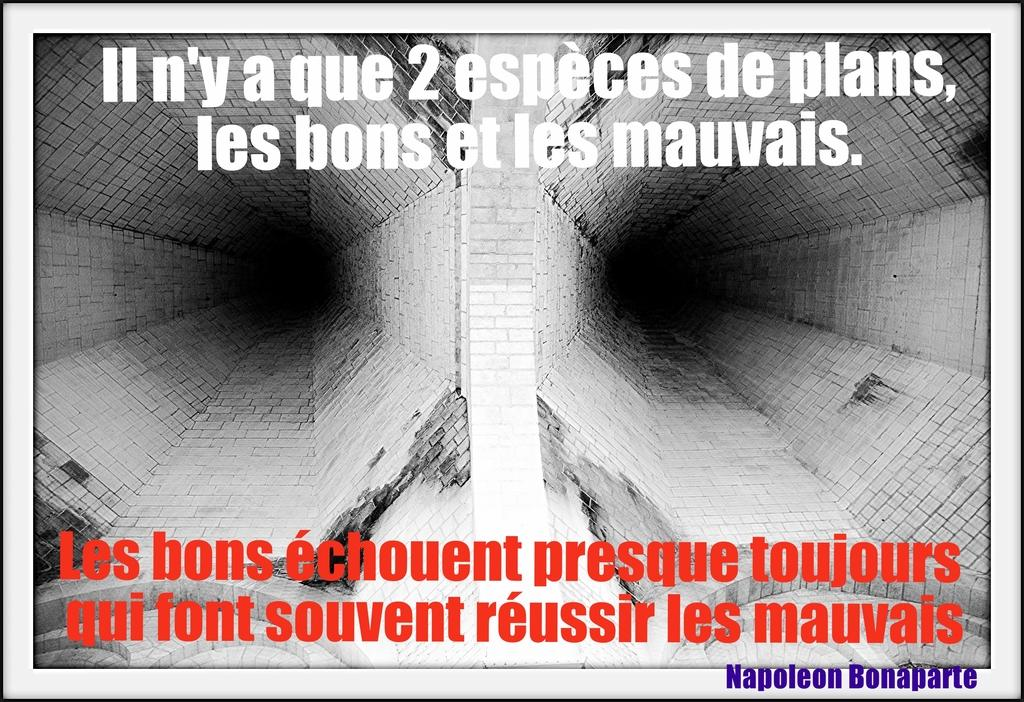<image>
Offer a succinct explanation of the picture presented. A sign in French is saying something about Napoleon. 